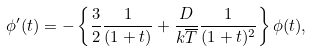Convert formula to latex. <formula><loc_0><loc_0><loc_500><loc_500>\phi ^ { \prime } ( t ) = - \left \{ \frac { 3 } { 2 } \frac { 1 } { ( 1 + t ) } + \frac { D } { k \overline { T } } \frac { 1 } { ( 1 + t ) ^ { 2 } } \right \} \phi ( t ) ,</formula> 